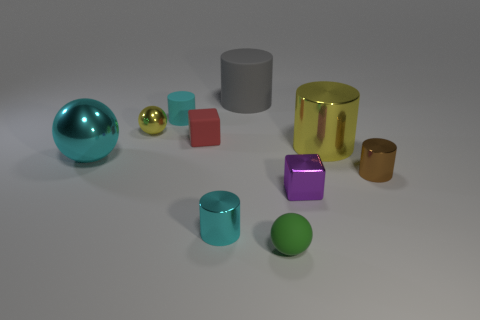Subtract all yellow cylinders. How many cylinders are left? 4 Subtract all small cyan cylinders. How many cylinders are left? 3 Subtract 2 cylinders. How many cylinders are left? 3 Subtract all brown cylinders. Subtract all cyan blocks. How many cylinders are left? 4 Subtract all balls. How many objects are left? 7 Add 2 tiny purple matte balls. How many tiny purple matte balls exist? 2 Subtract 0 red cylinders. How many objects are left? 10 Subtract all big yellow metal things. Subtract all large blue metallic things. How many objects are left? 9 Add 9 gray matte cylinders. How many gray matte cylinders are left? 10 